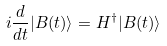<formula> <loc_0><loc_0><loc_500><loc_500>i \frac { d } { d t } | B ( t ) \rangle = H ^ { \dagger } | B ( t ) \rangle</formula> 